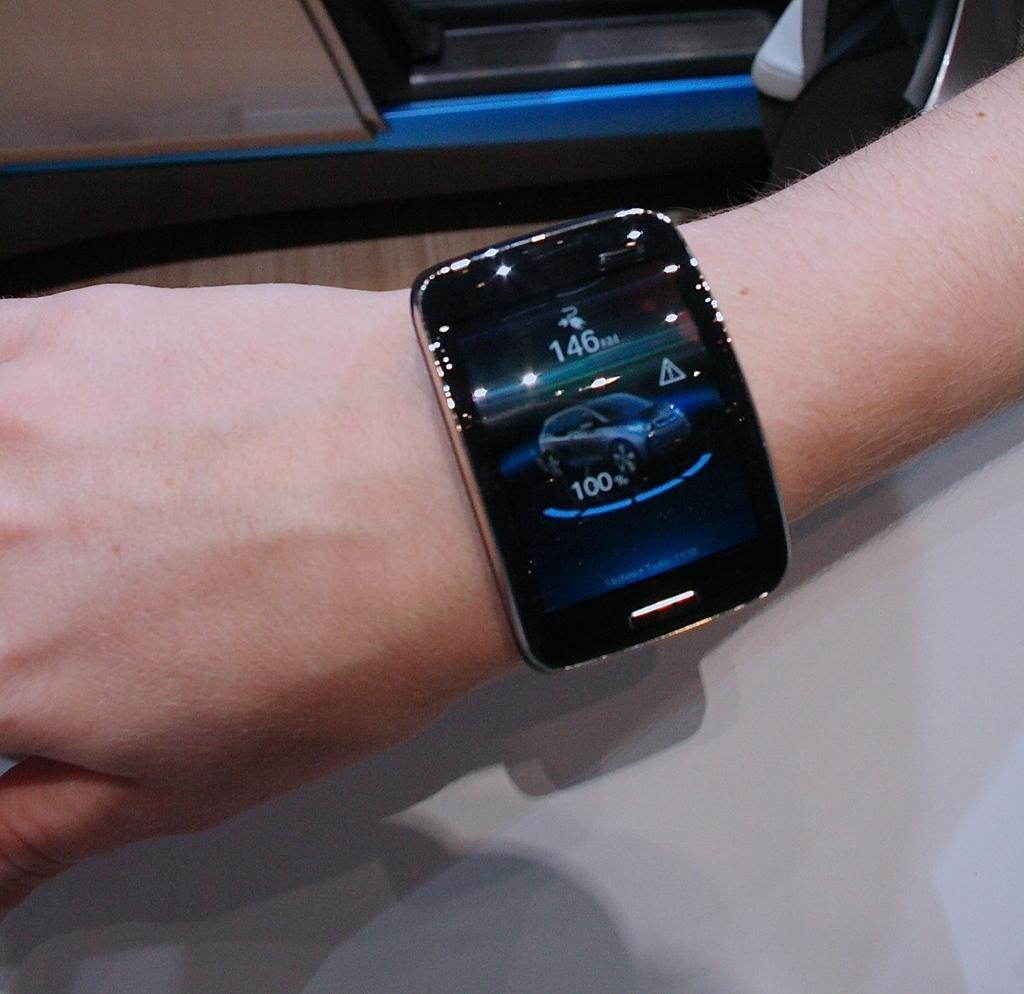<image>
Render a clear and concise summary of the photo. Person wearing a watch taht says 146 on it. 